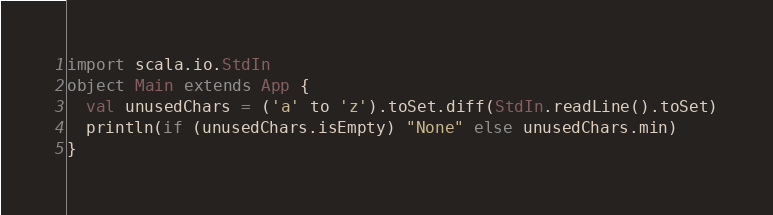<code> <loc_0><loc_0><loc_500><loc_500><_Scala_>import scala.io.StdIn
object Main extends App {
  val unusedChars = ('a' to 'z').toSet.diff(StdIn.readLine().toSet)
  println(if (unusedChars.isEmpty) "None" else unusedChars.min)
}
</code> 